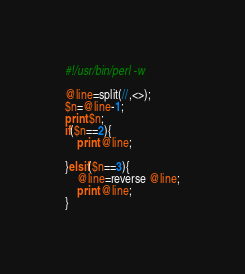Convert code to text. <code><loc_0><loc_0><loc_500><loc_500><_Perl_>#!/usr/bin/perl -w

@line=split(//,<>);
$n=@line-1;
print $n;
if($n==2){
    print @line;

}elsif($n==3){
    @line=reverse @line;
    print @line;
}
</code> 